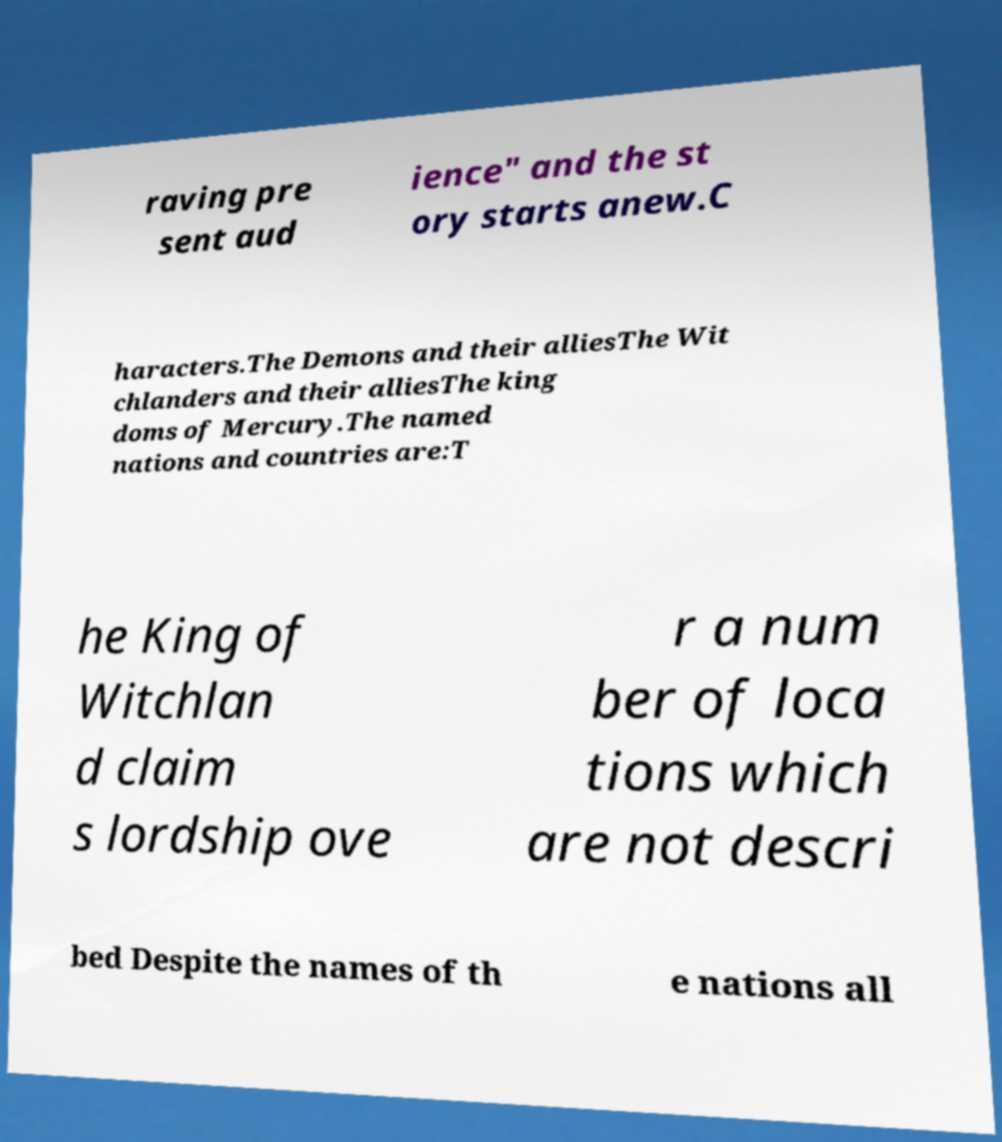Please identify and transcribe the text found in this image. raving pre sent aud ience" and the st ory starts anew.C haracters.The Demons and their alliesThe Wit chlanders and their alliesThe king doms of Mercury.The named nations and countries are:T he King of Witchlan d claim s lordship ove r a num ber of loca tions which are not descri bed Despite the names of th e nations all 